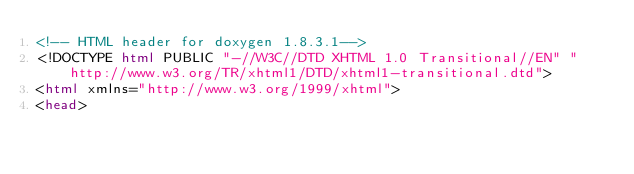<code> <loc_0><loc_0><loc_500><loc_500><_HTML_><!-- HTML header for doxygen 1.8.3.1-->
<!DOCTYPE html PUBLIC "-//W3C//DTD XHTML 1.0 Transitional//EN" "http://www.w3.org/TR/xhtml1/DTD/xhtml1-transitional.dtd">
<html xmlns="http://www.w3.org/1999/xhtml">
<head></code> 